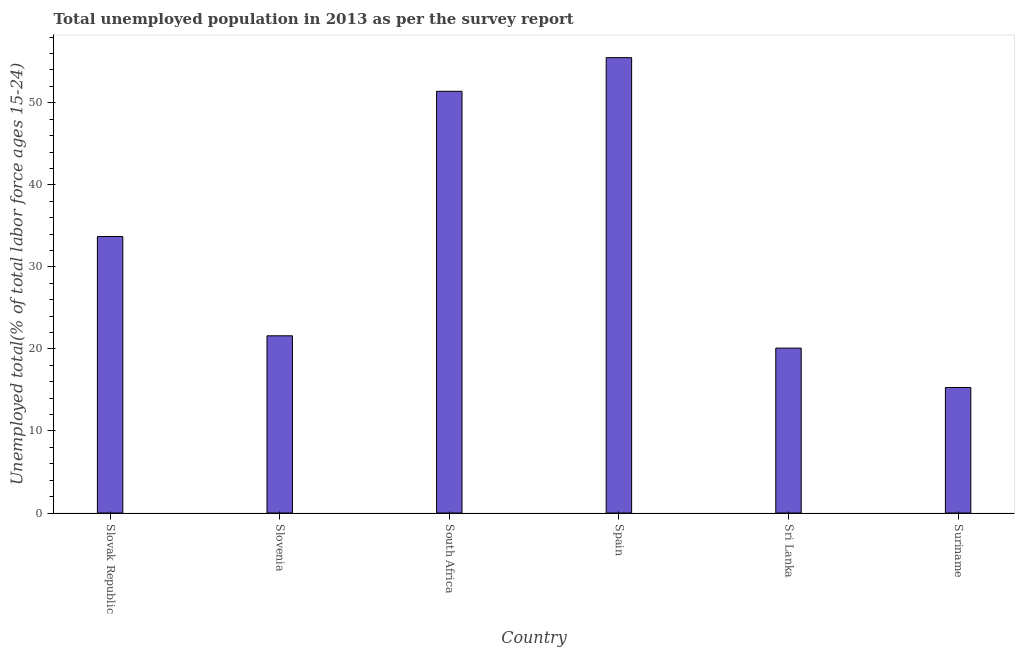Does the graph contain any zero values?
Your answer should be compact. No. What is the title of the graph?
Make the answer very short. Total unemployed population in 2013 as per the survey report. What is the label or title of the Y-axis?
Your answer should be very brief. Unemployed total(% of total labor force ages 15-24). What is the unemployed youth in South Africa?
Your answer should be very brief. 51.4. Across all countries, what is the maximum unemployed youth?
Make the answer very short. 55.5. Across all countries, what is the minimum unemployed youth?
Keep it short and to the point. 15.3. In which country was the unemployed youth minimum?
Make the answer very short. Suriname. What is the sum of the unemployed youth?
Offer a terse response. 197.6. What is the difference between the unemployed youth in Slovak Republic and Sri Lanka?
Your response must be concise. 13.6. What is the average unemployed youth per country?
Offer a terse response. 32.93. What is the median unemployed youth?
Ensure brevity in your answer.  27.65. What is the ratio of the unemployed youth in Slovenia to that in Sri Lanka?
Keep it short and to the point. 1.07. Is the unemployed youth in Slovak Republic less than that in Slovenia?
Provide a succinct answer. No. Is the sum of the unemployed youth in Slovak Republic and South Africa greater than the maximum unemployed youth across all countries?
Ensure brevity in your answer.  Yes. What is the difference between the highest and the lowest unemployed youth?
Make the answer very short. 40.2. In how many countries, is the unemployed youth greater than the average unemployed youth taken over all countries?
Ensure brevity in your answer.  3. Are all the bars in the graph horizontal?
Offer a terse response. No. What is the Unemployed total(% of total labor force ages 15-24) in Slovak Republic?
Your answer should be compact. 33.7. What is the Unemployed total(% of total labor force ages 15-24) in Slovenia?
Offer a terse response. 21.6. What is the Unemployed total(% of total labor force ages 15-24) of South Africa?
Ensure brevity in your answer.  51.4. What is the Unemployed total(% of total labor force ages 15-24) in Spain?
Keep it short and to the point. 55.5. What is the Unemployed total(% of total labor force ages 15-24) in Sri Lanka?
Provide a short and direct response. 20.1. What is the Unemployed total(% of total labor force ages 15-24) of Suriname?
Give a very brief answer. 15.3. What is the difference between the Unemployed total(% of total labor force ages 15-24) in Slovak Republic and Slovenia?
Offer a terse response. 12.1. What is the difference between the Unemployed total(% of total labor force ages 15-24) in Slovak Republic and South Africa?
Ensure brevity in your answer.  -17.7. What is the difference between the Unemployed total(% of total labor force ages 15-24) in Slovak Republic and Spain?
Ensure brevity in your answer.  -21.8. What is the difference between the Unemployed total(% of total labor force ages 15-24) in Slovak Republic and Sri Lanka?
Offer a terse response. 13.6. What is the difference between the Unemployed total(% of total labor force ages 15-24) in Slovenia and South Africa?
Provide a succinct answer. -29.8. What is the difference between the Unemployed total(% of total labor force ages 15-24) in Slovenia and Spain?
Provide a succinct answer. -33.9. What is the difference between the Unemployed total(% of total labor force ages 15-24) in Slovenia and Suriname?
Ensure brevity in your answer.  6.3. What is the difference between the Unemployed total(% of total labor force ages 15-24) in South Africa and Spain?
Make the answer very short. -4.1. What is the difference between the Unemployed total(% of total labor force ages 15-24) in South Africa and Sri Lanka?
Offer a terse response. 31.3. What is the difference between the Unemployed total(% of total labor force ages 15-24) in South Africa and Suriname?
Keep it short and to the point. 36.1. What is the difference between the Unemployed total(% of total labor force ages 15-24) in Spain and Sri Lanka?
Provide a short and direct response. 35.4. What is the difference between the Unemployed total(% of total labor force ages 15-24) in Spain and Suriname?
Your answer should be compact. 40.2. What is the difference between the Unemployed total(% of total labor force ages 15-24) in Sri Lanka and Suriname?
Your answer should be very brief. 4.8. What is the ratio of the Unemployed total(% of total labor force ages 15-24) in Slovak Republic to that in Slovenia?
Keep it short and to the point. 1.56. What is the ratio of the Unemployed total(% of total labor force ages 15-24) in Slovak Republic to that in South Africa?
Your response must be concise. 0.66. What is the ratio of the Unemployed total(% of total labor force ages 15-24) in Slovak Republic to that in Spain?
Offer a terse response. 0.61. What is the ratio of the Unemployed total(% of total labor force ages 15-24) in Slovak Republic to that in Sri Lanka?
Keep it short and to the point. 1.68. What is the ratio of the Unemployed total(% of total labor force ages 15-24) in Slovak Republic to that in Suriname?
Provide a short and direct response. 2.2. What is the ratio of the Unemployed total(% of total labor force ages 15-24) in Slovenia to that in South Africa?
Provide a short and direct response. 0.42. What is the ratio of the Unemployed total(% of total labor force ages 15-24) in Slovenia to that in Spain?
Your answer should be compact. 0.39. What is the ratio of the Unemployed total(% of total labor force ages 15-24) in Slovenia to that in Sri Lanka?
Give a very brief answer. 1.07. What is the ratio of the Unemployed total(% of total labor force ages 15-24) in Slovenia to that in Suriname?
Your response must be concise. 1.41. What is the ratio of the Unemployed total(% of total labor force ages 15-24) in South Africa to that in Spain?
Your answer should be compact. 0.93. What is the ratio of the Unemployed total(% of total labor force ages 15-24) in South Africa to that in Sri Lanka?
Your answer should be very brief. 2.56. What is the ratio of the Unemployed total(% of total labor force ages 15-24) in South Africa to that in Suriname?
Your answer should be very brief. 3.36. What is the ratio of the Unemployed total(% of total labor force ages 15-24) in Spain to that in Sri Lanka?
Provide a short and direct response. 2.76. What is the ratio of the Unemployed total(% of total labor force ages 15-24) in Spain to that in Suriname?
Make the answer very short. 3.63. What is the ratio of the Unemployed total(% of total labor force ages 15-24) in Sri Lanka to that in Suriname?
Provide a short and direct response. 1.31. 